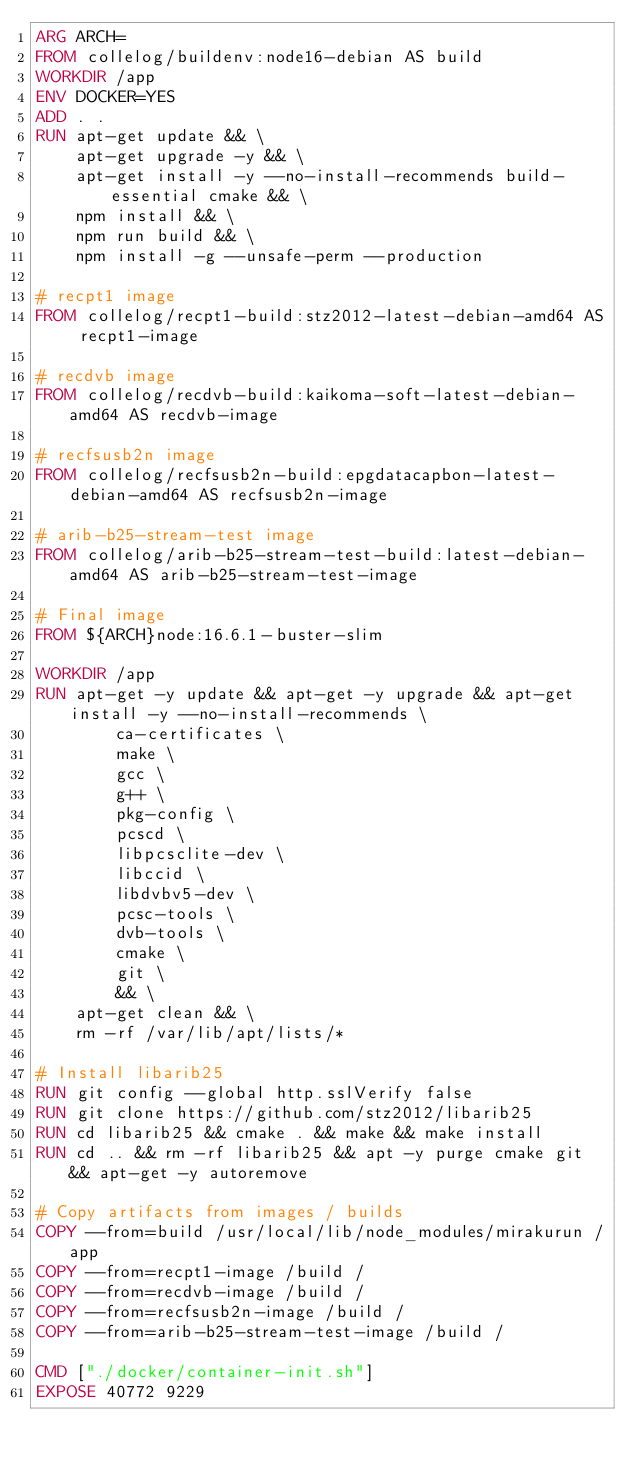Convert code to text. <code><loc_0><loc_0><loc_500><loc_500><_Dockerfile_>ARG ARCH=
FROM collelog/buildenv:node16-debian AS build
WORKDIR /app
ENV DOCKER=YES
ADD . .
RUN apt-get update && \
    apt-get upgrade -y && \
    apt-get install -y --no-install-recommends build-essential cmake && \
    npm install && \
    npm run build && \
    npm install -g --unsafe-perm --production

# recpt1 image
FROM collelog/recpt1-build:stz2012-latest-debian-amd64 AS recpt1-image

# recdvb image
FROM collelog/recdvb-build:kaikoma-soft-latest-debian-amd64 AS recdvb-image

# recfsusb2n image
FROM collelog/recfsusb2n-build:epgdatacapbon-latest-debian-amd64 AS recfsusb2n-image

# arib-b25-stream-test image
FROM collelog/arib-b25-stream-test-build:latest-debian-amd64 AS arib-b25-stream-test-image

# Final image
FROM ${ARCH}node:16.6.1-buster-slim

WORKDIR /app
RUN apt-get -y update && apt-get -y upgrade && apt-get install -y --no-install-recommends \
        ca-certificates \
        make \
        gcc \
        g++ \
        pkg-config \
        pcscd \
        libpcsclite-dev \
        libccid \
        libdvbv5-dev \
        pcsc-tools \
        dvb-tools \
        cmake \
        git \
        && \
    apt-get clean && \
    rm -rf /var/lib/apt/lists/*

# Install libarib25
RUN git config --global http.sslVerify false
RUN git clone https://github.com/stz2012/libarib25
RUN cd libarib25 && cmake . && make && make install
RUN cd .. && rm -rf libarib25 && apt -y purge cmake git && apt-get -y autoremove

# Copy artifacts from images / builds
COPY --from=build /usr/local/lib/node_modules/mirakurun /app
COPY --from=recpt1-image /build /
COPY --from=recdvb-image /build /
COPY --from=recfsusb2n-image /build /
COPY --from=arib-b25-stream-test-image /build /

CMD ["./docker/container-init.sh"]
EXPOSE 40772 9229
</code> 